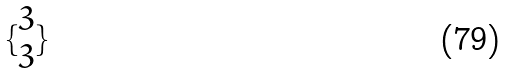Convert formula to latex. <formula><loc_0><loc_0><loc_500><loc_500>\{ \begin{matrix} 3 \\ 3 \end{matrix} \}</formula> 